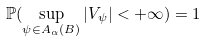<formula> <loc_0><loc_0><loc_500><loc_500>\mathbb { P } ( \sup _ { \psi \in A _ { \alpha } ( B ) } | V _ { \psi } | < + \infty ) = 1</formula> 